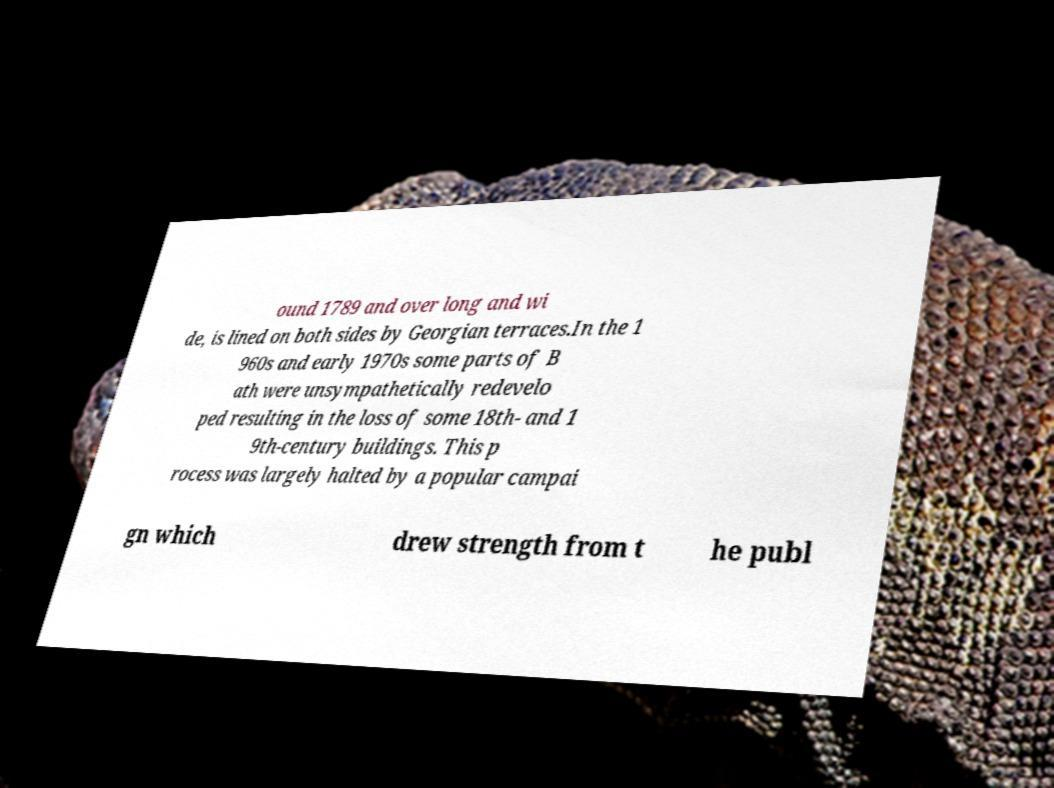For documentation purposes, I need the text within this image transcribed. Could you provide that? ound 1789 and over long and wi de, is lined on both sides by Georgian terraces.In the 1 960s and early 1970s some parts of B ath were unsympathetically redevelo ped resulting in the loss of some 18th- and 1 9th-century buildings. This p rocess was largely halted by a popular campai gn which drew strength from t he publ 